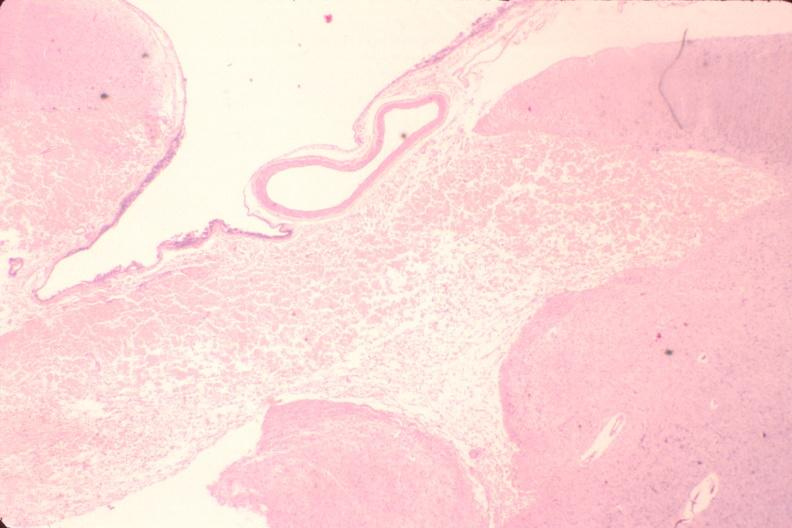what is present?
Answer the question using a single word or phrase. Nervous 